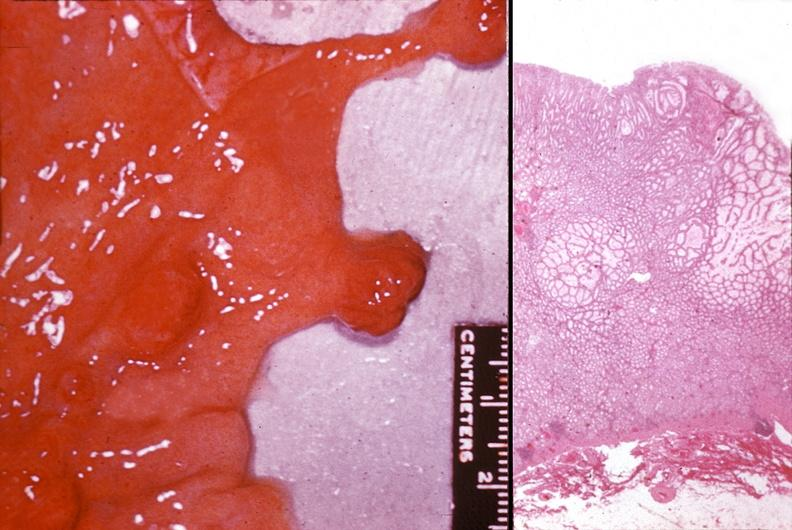s gastrointestinal present?
Answer the question using a single word or phrase. Yes 